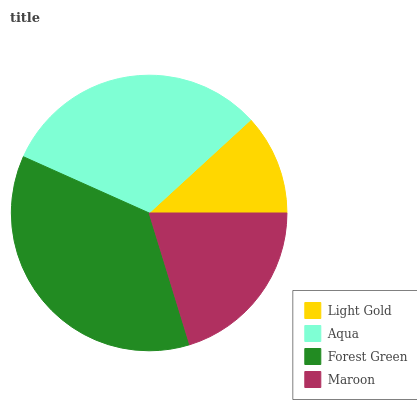Is Light Gold the minimum?
Answer yes or no. Yes. Is Forest Green the maximum?
Answer yes or no. Yes. Is Aqua the minimum?
Answer yes or no. No. Is Aqua the maximum?
Answer yes or no. No. Is Aqua greater than Light Gold?
Answer yes or no. Yes. Is Light Gold less than Aqua?
Answer yes or no. Yes. Is Light Gold greater than Aqua?
Answer yes or no. No. Is Aqua less than Light Gold?
Answer yes or no. No. Is Aqua the high median?
Answer yes or no. Yes. Is Maroon the low median?
Answer yes or no. Yes. Is Maroon the high median?
Answer yes or no. No. Is Light Gold the low median?
Answer yes or no. No. 